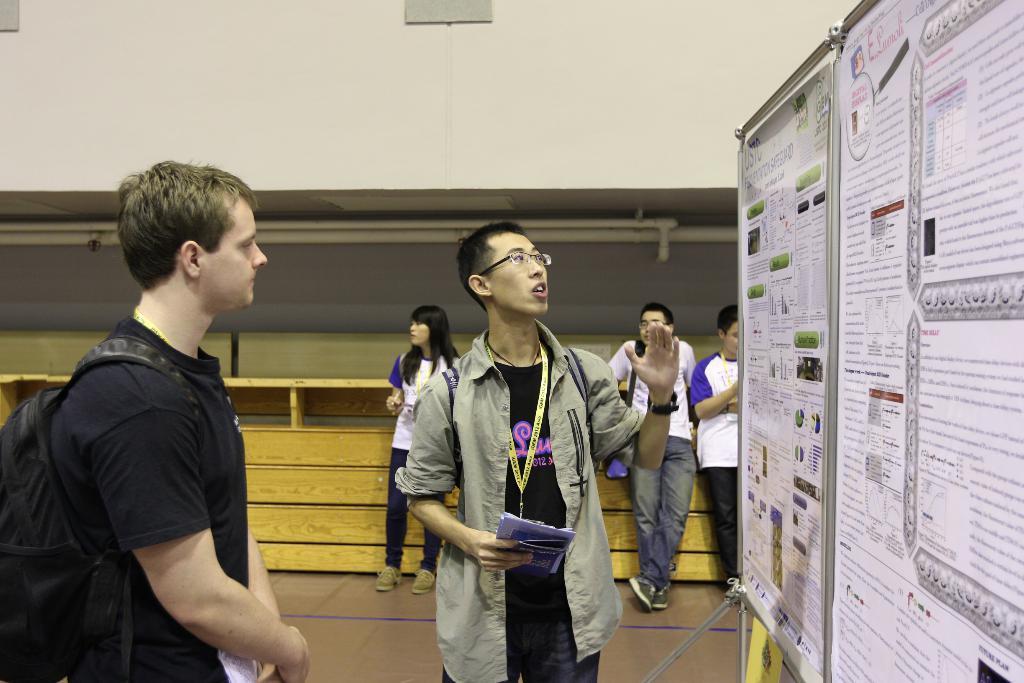Can you describe this image briefly? This picture describes about group of people, in the middle of the image we can see a man, he wore spectacles and he is holding books, beside to him we can find few papers on the board, on the left side of the image we can find another man, he wore a bag. 